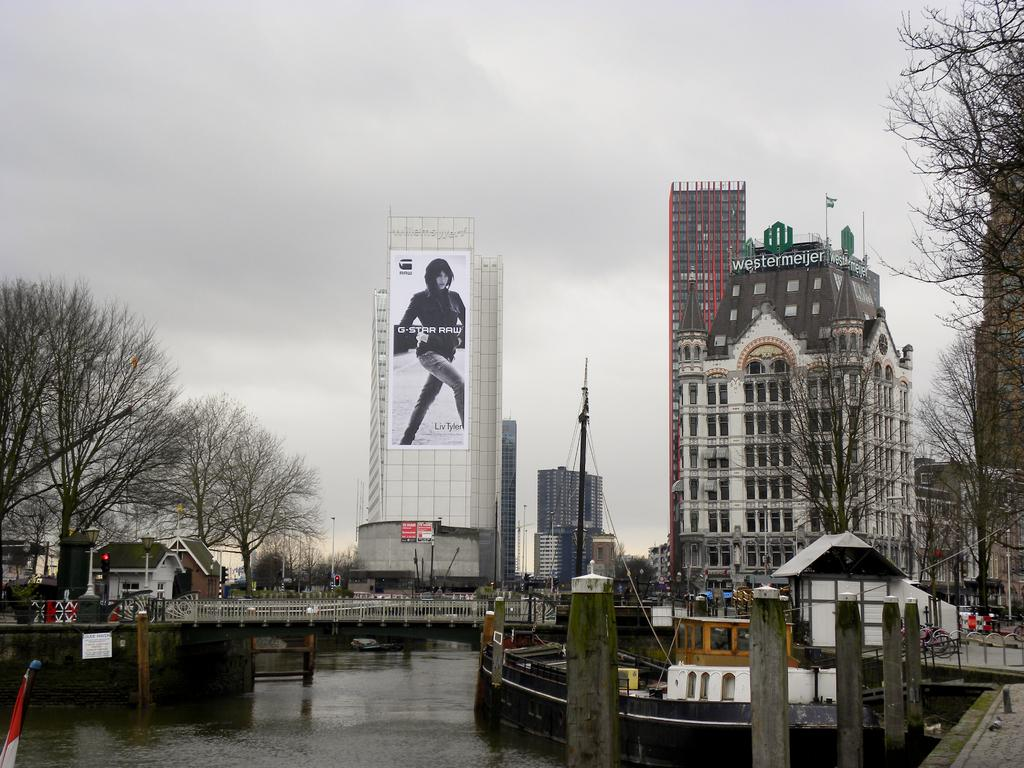What type of structure can be seen in the image? There is a bridge in the image. What other natural elements are present in the image? There are trees in the image. Are there any man-made structures visible in the image? Yes, there are buildings in the image. What is at the bottom of the image? There is a surface of water at the bottom of the image. What can be seen in the background of the image? The sky is visible in the background of the image. What type of amusement can be seen in the image? There is no amusement present in the image; it features a bridge, trees, buildings, water, and sky. What color is the vest worn by the person in the image? There is no person wearing a vest in the image. What type of club is visible in the image? There is no club present in the image. 